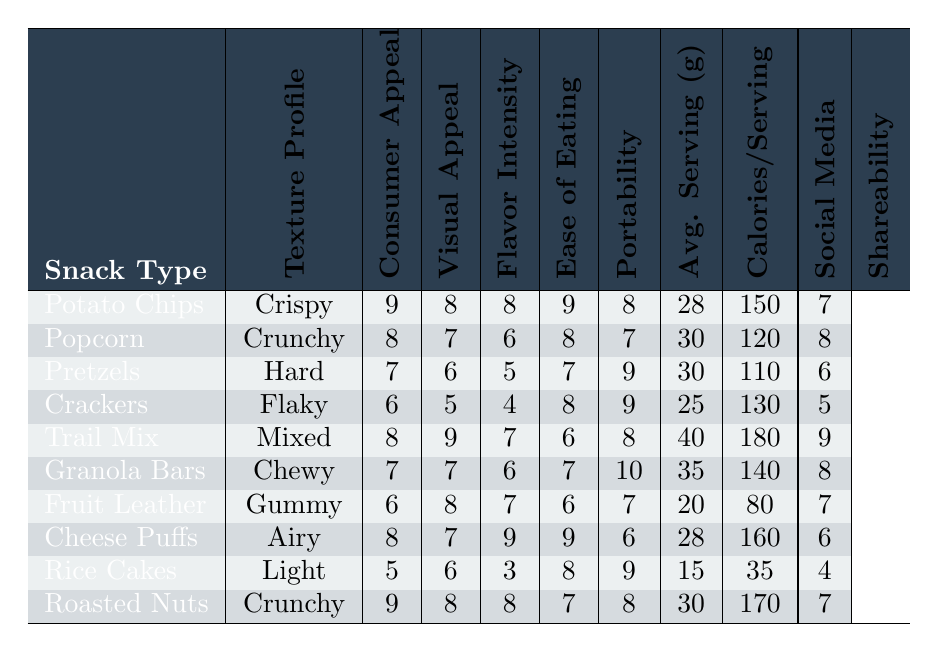What is the texture profile of cheese puffs? Looking at the table, the texture profile for cheese puffs is listed directly in the second column.
Answer: Airy Which snack has the highest consumer appeal score? By examining the "Consumer Appeal" column, I see that potato chips have the highest score of 9.
Answer: Potato Chips What is the average visual appeal for snacks with a chewy texture? The only snack with a chewy texture is granola bars, which has a visual appeal rating of 7. Thus, the average is also 7.
Answer: 7 Is the average calorie content for trail mix higher than that of cheese puffs? Trail mix has 180 calories and cheese puffs have 160 calories. Since 180 is greater than 160, the statement is true.
Answer: Yes What is the total ease of eating score for all snacks? Summing the "Ease of Eating" scores: 9 + 8 + 7 + 8 + 6 + 7 + 6 + 9 + 8 + 7 = 78.
Answer: 78 Which snacks have a flavor intensity score of 6 or less? The snacks that have a flavor intensity score of 6 or less are pretzels (5), crackers (4), and popcorn (6).
Answer: Pretzels, Crackers, Popcorn What is the difference in portability scores between granola bars and rice cakes? Granola bars have a portability score of 10, while rice cakes have a score of 9. The difference is 10 - 9 = 1.
Answer: 1 What percentage of snacks have a social media shareability score of 7 or higher? There are 10 snacks in total. The snacks with a score of 7 or higher are: potato chips (7), popcorn (8), trail mix (9), granola bars (8), and roasted nuts (7) totaling 5 snacks. The percentage is (5/10) * 100 = 50%.
Answer: 50% Which snack type has the lowest average serving size, and what is that weight? By analyzing the "Avg. Serving (g)" column, rice cakes have the lowest average serving size at 15 grams.
Answer: Rice Cakes, 15 grams How does the visual appeal score of crackers compare to that of pretzels? Crackers have a visual appeal score of 5, while pretzels score 6. Since 5 is less than 6, crackers have a lower score.
Answer: Lower than Pretzels 